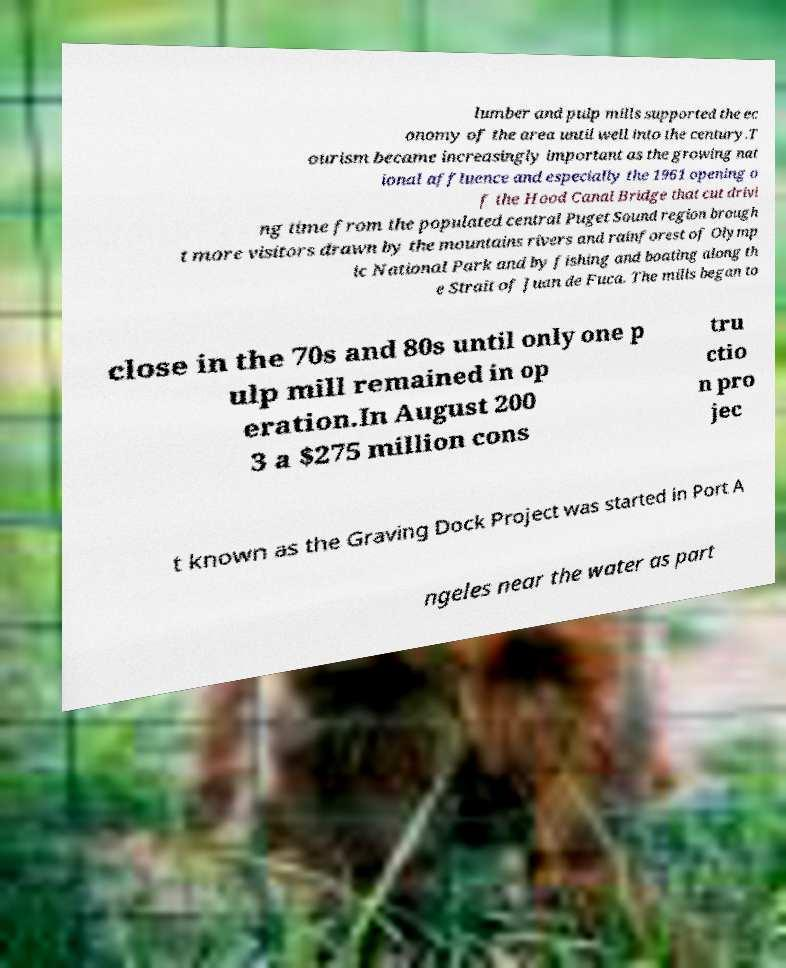Could you extract and type out the text from this image? lumber and pulp mills supported the ec onomy of the area until well into the century.T ourism became increasingly important as the growing nat ional affluence and especially the 1961 opening o f the Hood Canal Bridge that cut drivi ng time from the populated central Puget Sound region brough t more visitors drawn by the mountains rivers and rainforest of Olymp ic National Park and by fishing and boating along th e Strait of Juan de Fuca. The mills began to close in the 70s and 80s until only one p ulp mill remained in op eration.In August 200 3 a $275 million cons tru ctio n pro jec t known as the Graving Dock Project was started in Port A ngeles near the water as part 